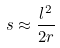Convert formula to latex. <formula><loc_0><loc_0><loc_500><loc_500>s \approx \frac { l ^ { 2 } } { 2 r }</formula> 